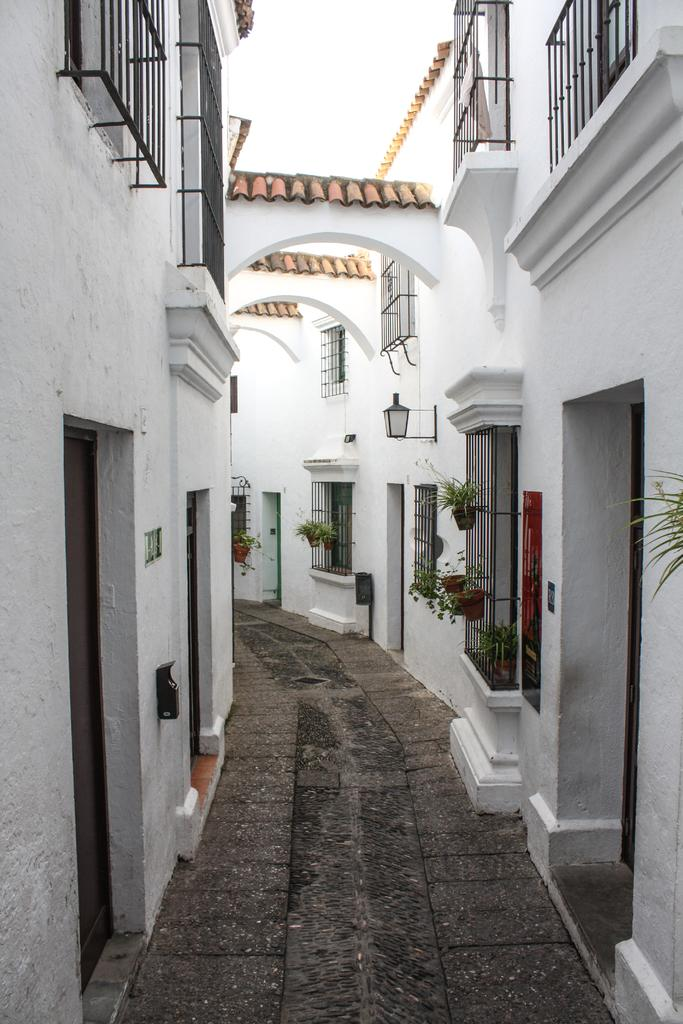What type of structures can be seen in the image? There are buildings in the image. What type of vegetation is present in the image? There are plants in pots in the image. What can be seen on the wall in the image? There is light on the wall in the image. What type of toys can be seen in the image? There are no toys present in the image. How much payment is required to enter the building in the image? There is no indication of payment or entrance fees in the image. 